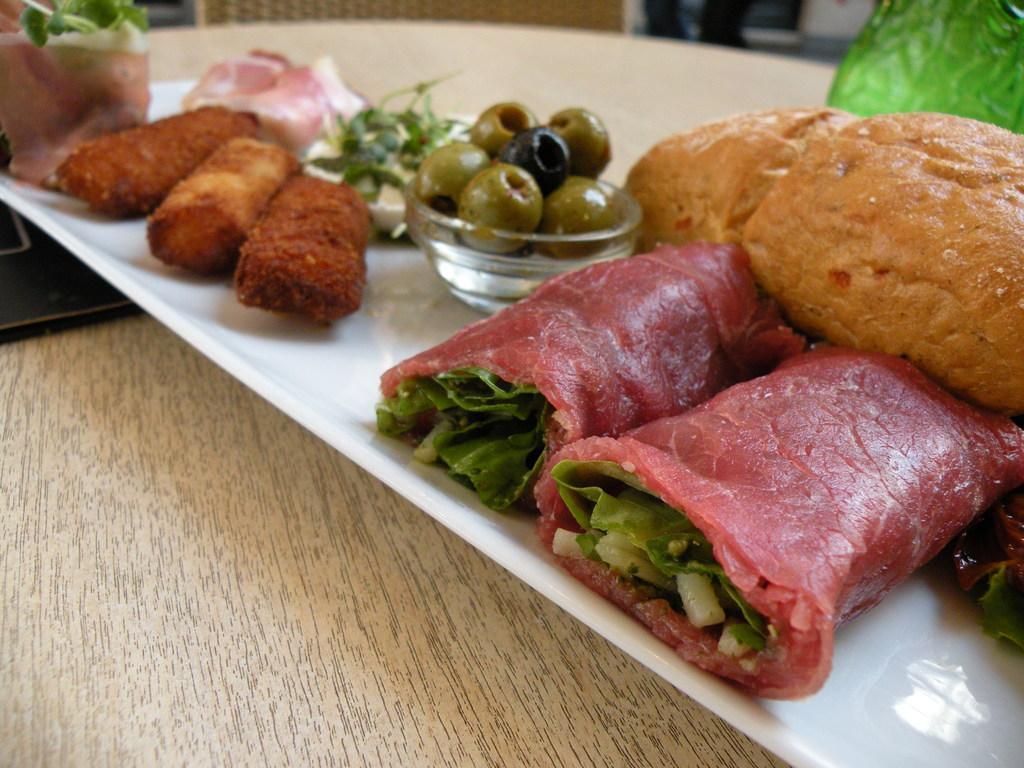In one or two sentences, can you explain what this image depicts? In this image there is one plate and in the plate there are some fruits and some food items. At the bottom it looks like a table, in the background there are some objects. 